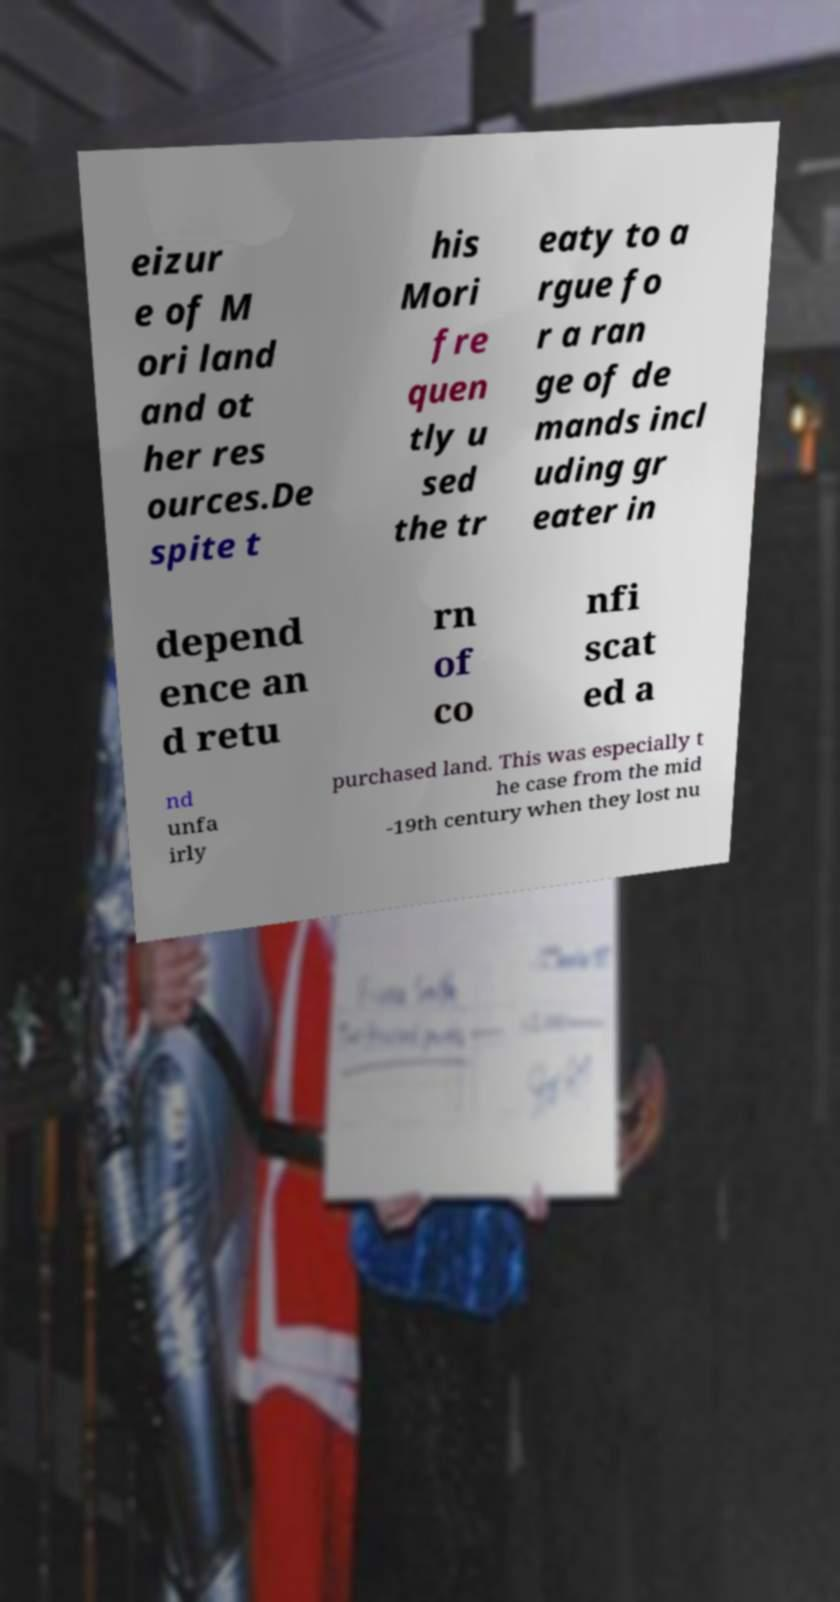Can you accurately transcribe the text from the provided image for me? eizur e of M ori land and ot her res ources.De spite t his Mori fre quen tly u sed the tr eaty to a rgue fo r a ran ge of de mands incl uding gr eater in depend ence an d retu rn of co nfi scat ed a nd unfa irly purchased land. This was especially t he case from the mid -19th century when they lost nu 